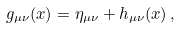Convert formula to latex. <formula><loc_0><loc_0><loc_500><loc_500>g _ { \mu \nu } ( x ) = \eta _ { \mu \nu } + h _ { \mu \nu } ( x ) \, ,</formula> 